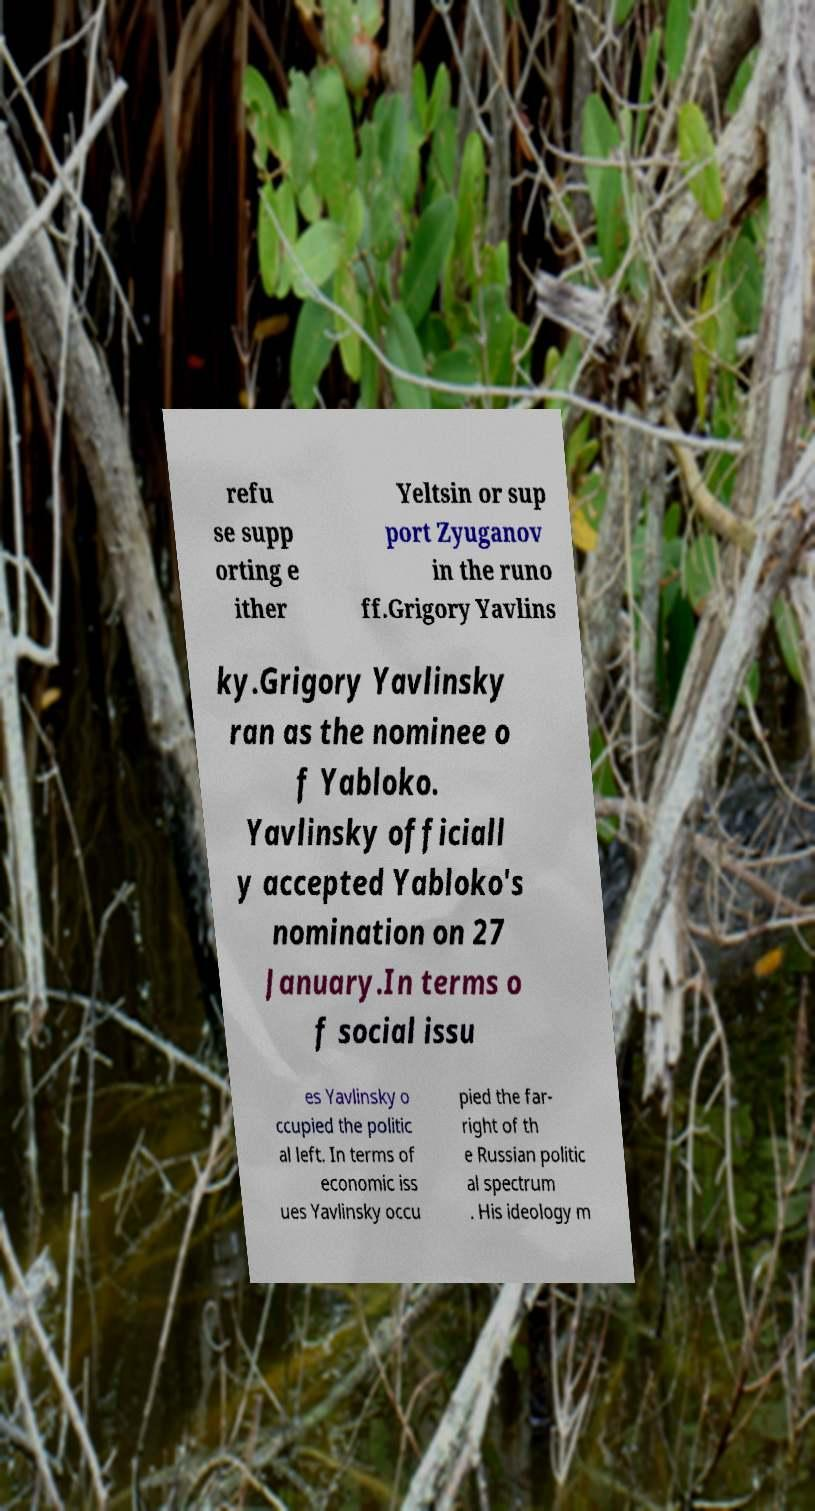Can you read and provide the text displayed in the image?This photo seems to have some interesting text. Can you extract and type it out for me? refu se supp orting e ither Yeltsin or sup port Zyuganov in the runo ff.Grigory Yavlins ky.Grigory Yavlinsky ran as the nominee o f Yabloko. Yavlinsky officiall y accepted Yabloko's nomination on 27 January.In terms o f social issu es Yavlinsky o ccupied the politic al left. In terms of economic iss ues Yavlinsky occu pied the far- right of th e Russian politic al spectrum . His ideology m 